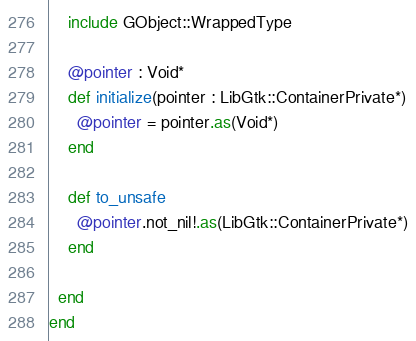<code> <loc_0><loc_0><loc_500><loc_500><_Crystal_>    include GObject::WrappedType

    @pointer : Void*
    def initialize(pointer : LibGtk::ContainerPrivate*)
      @pointer = pointer.as(Void*)
    end

    def to_unsafe
      @pointer.not_nil!.as(LibGtk::ContainerPrivate*)
    end

  end
end

</code> 